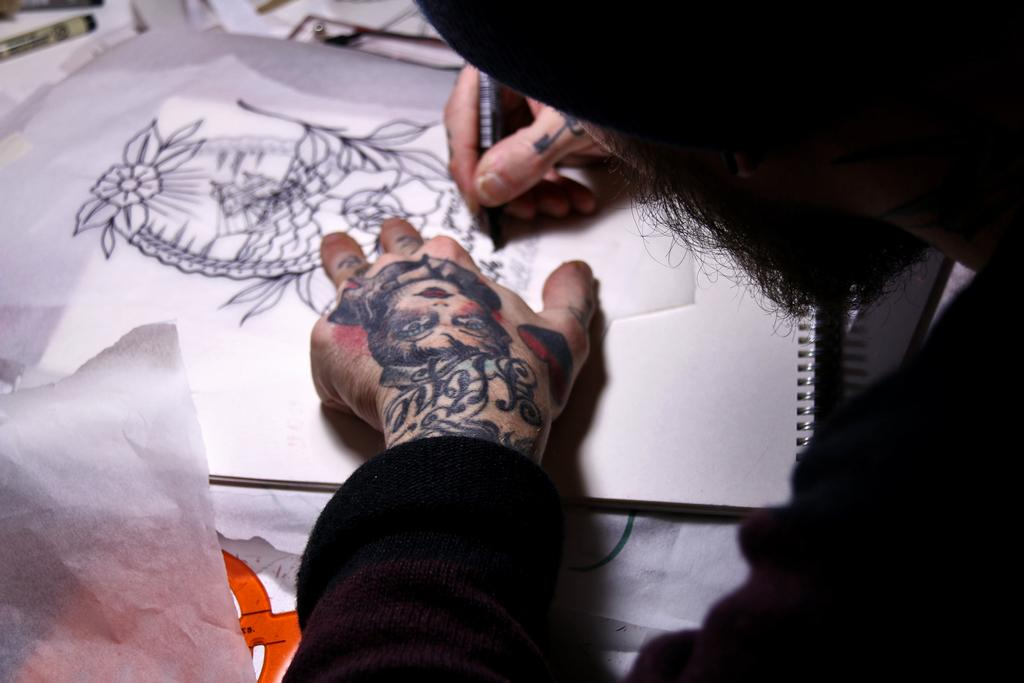What is the person in the image doing? The person is drawing on a book. What can be seen on the person's hand in the image? The person has a tattoo on their hand. What else is visible in the image besides the person and their drawing? There are papers visible in the image. What type of pail is being used to hold the person's drawing materials in the image? There is no pail present in the image; the person is drawing on a book. How does the person's aunt help them with their drawing in the image? There is no mention of an aunt in the image, and the person is drawing on their own. 